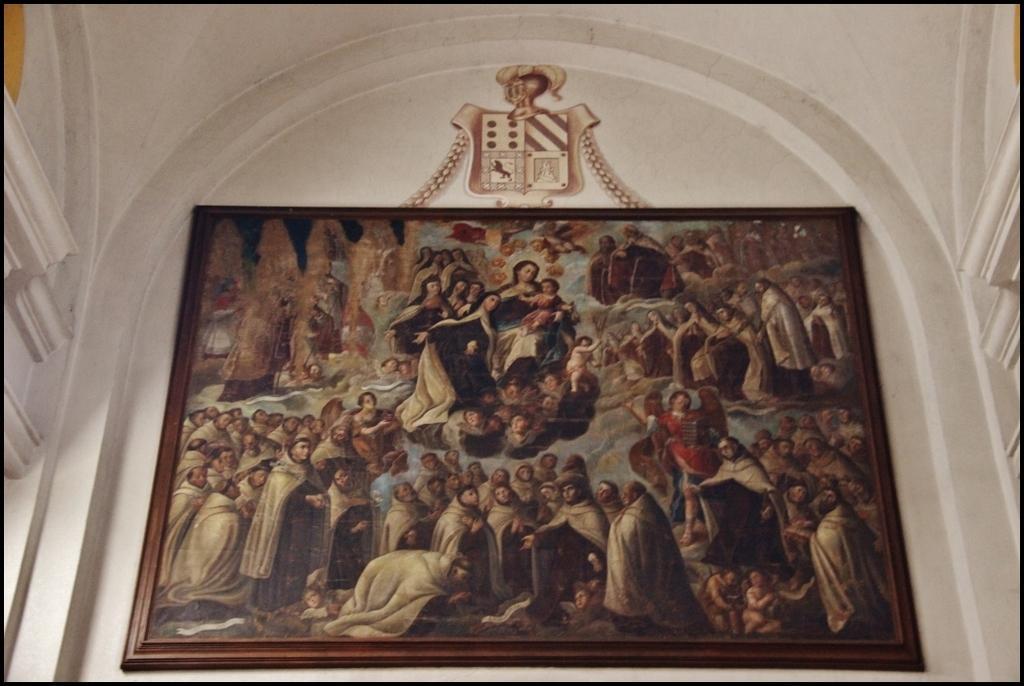In one or two sentences, can you explain what this image depicts? In the image there is a frame with painting. And the frame is on the wall. 